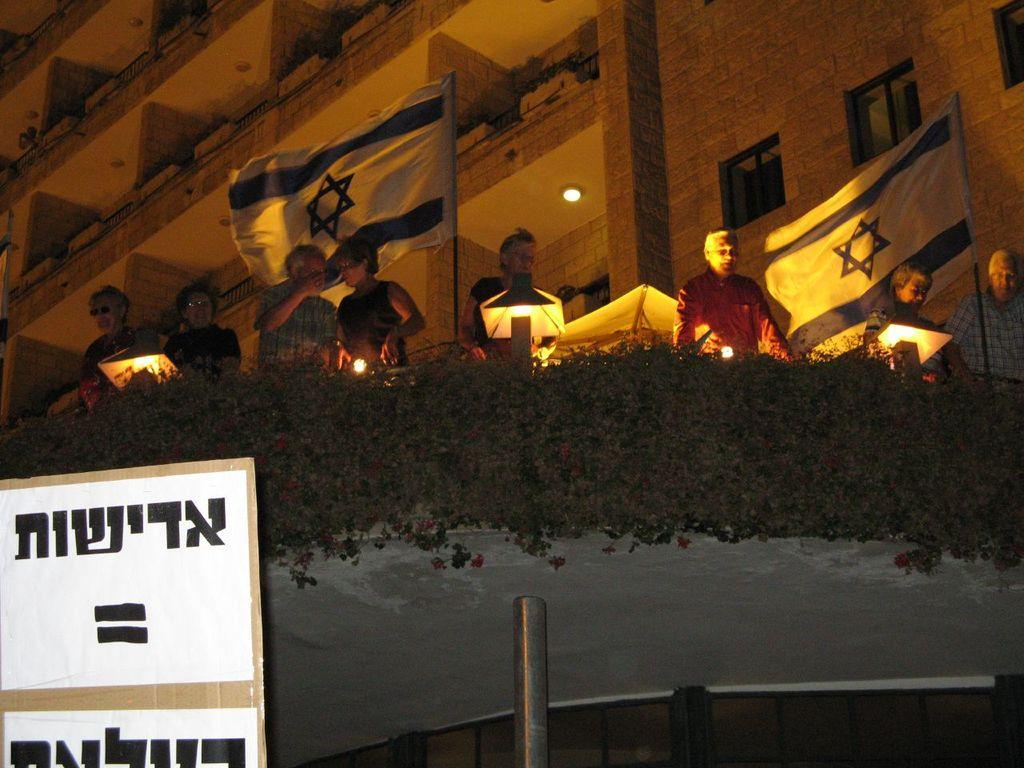What is located in the foreground of the image? There is a cardboard and a pole in the foreground of the image. What is on top of the pole? There are plants, lights, flags, and persons standing on top of the pole. What can be seen in the background of the image? There is a building visible in the image. What type of crate can be seen in the image? There is no crate present in the image. How does the fog affect the visibility of the persons standing on top of the pole? There is no fog present in the image, so it does not affect the visibility of the persons standing on top of the pole. 